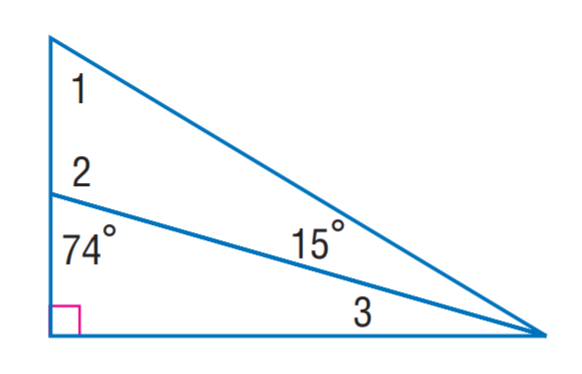Answer the mathemtical geometry problem and directly provide the correct option letter.
Question: Find m \angle 3.
Choices: A: 15 B: 16 C: 18 D: 20 B 